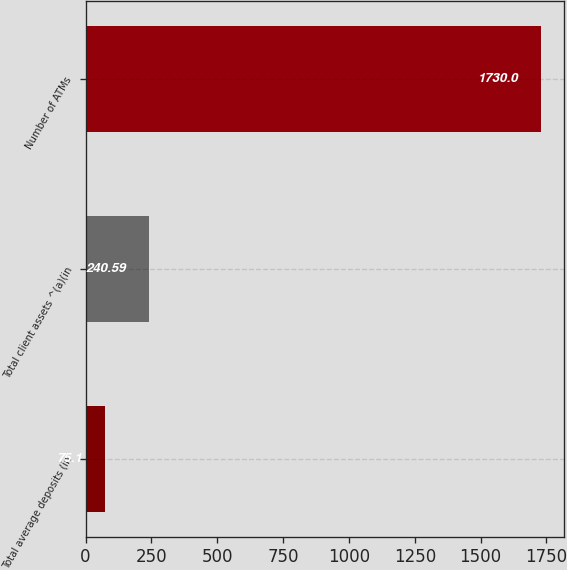<chart> <loc_0><loc_0><loc_500><loc_500><bar_chart><fcel>Total average deposits (in<fcel>Total client assets ^(a)(in<fcel>Number of ATMs<nl><fcel>75.1<fcel>240.59<fcel>1730<nl></chart> 